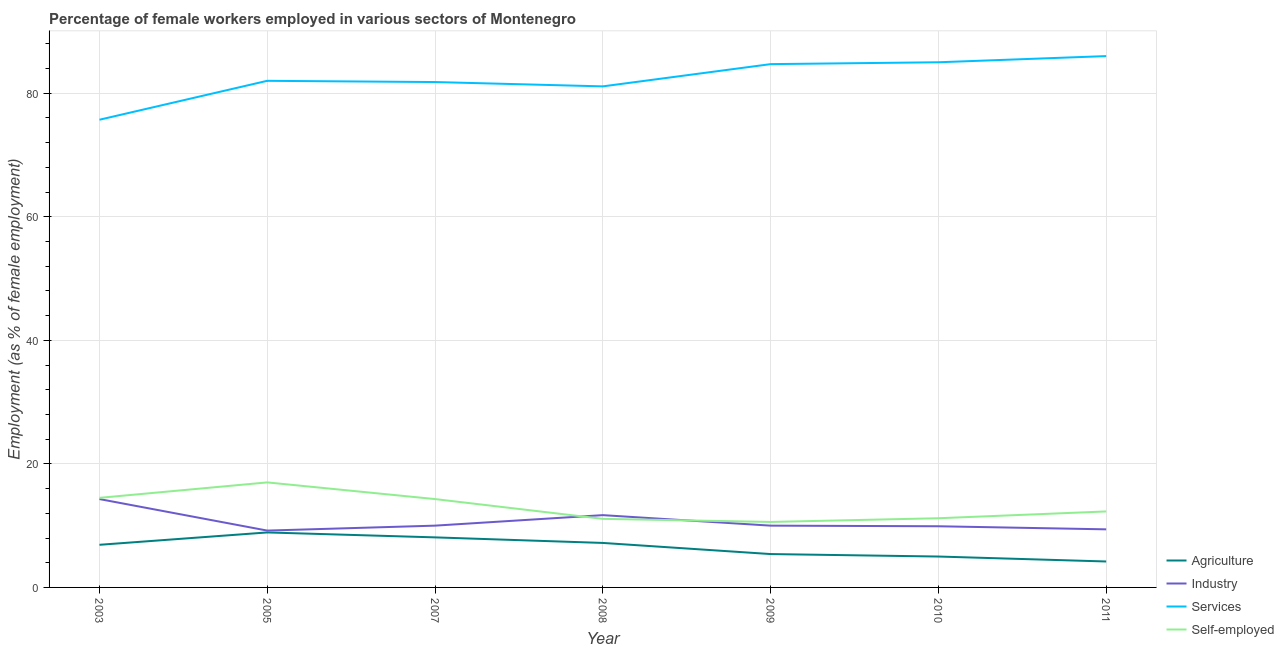Does the line corresponding to percentage of female workers in services intersect with the line corresponding to percentage of female workers in agriculture?
Your answer should be very brief. No. Across all years, what is the minimum percentage of self employed female workers?
Provide a short and direct response. 10.6. In which year was the percentage of self employed female workers maximum?
Make the answer very short. 2005. In which year was the percentage of female workers in industry minimum?
Ensure brevity in your answer.  2005. What is the total percentage of self employed female workers in the graph?
Keep it short and to the point. 91. What is the difference between the percentage of female workers in services in 2011 and the percentage of self employed female workers in 2009?
Give a very brief answer. 75.4. What is the average percentage of female workers in industry per year?
Ensure brevity in your answer.  10.64. In the year 2008, what is the difference between the percentage of female workers in industry and percentage of female workers in agriculture?
Your answer should be compact. 4.5. What is the ratio of the percentage of female workers in services in 2003 to that in 2008?
Give a very brief answer. 0.93. Is the percentage of self employed female workers in 2003 less than that in 2009?
Provide a short and direct response. No. What is the difference between the highest and the second highest percentage of female workers in services?
Your answer should be compact. 1. What is the difference between the highest and the lowest percentage of female workers in services?
Offer a terse response. 10.3. Is the sum of the percentage of female workers in services in 2007 and 2011 greater than the maximum percentage of female workers in agriculture across all years?
Provide a short and direct response. Yes. Is it the case that in every year, the sum of the percentage of female workers in agriculture and percentage of female workers in services is greater than the sum of percentage of female workers in industry and percentage of self employed female workers?
Keep it short and to the point. No. How many years are there in the graph?
Provide a short and direct response. 7. What is the difference between two consecutive major ticks on the Y-axis?
Give a very brief answer. 20. Does the graph contain grids?
Provide a succinct answer. Yes. How many legend labels are there?
Make the answer very short. 4. How are the legend labels stacked?
Your response must be concise. Vertical. What is the title of the graph?
Offer a very short reply. Percentage of female workers employed in various sectors of Montenegro. What is the label or title of the X-axis?
Offer a very short reply. Year. What is the label or title of the Y-axis?
Give a very brief answer. Employment (as % of female employment). What is the Employment (as % of female employment) in Agriculture in 2003?
Keep it short and to the point. 6.9. What is the Employment (as % of female employment) of Industry in 2003?
Your response must be concise. 14.3. What is the Employment (as % of female employment) of Services in 2003?
Provide a succinct answer. 75.7. What is the Employment (as % of female employment) of Agriculture in 2005?
Offer a very short reply. 8.9. What is the Employment (as % of female employment) of Industry in 2005?
Your response must be concise. 9.2. What is the Employment (as % of female employment) of Agriculture in 2007?
Your answer should be compact. 8.1. What is the Employment (as % of female employment) of Services in 2007?
Your answer should be compact. 81.8. What is the Employment (as % of female employment) in Self-employed in 2007?
Offer a very short reply. 14.3. What is the Employment (as % of female employment) in Agriculture in 2008?
Offer a very short reply. 7.2. What is the Employment (as % of female employment) in Industry in 2008?
Make the answer very short. 11.7. What is the Employment (as % of female employment) of Services in 2008?
Your answer should be very brief. 81.1. What is the Employment (as % of female employment) of Self-employed in 2008?
Keep it short and to the point. 11.1. What is the Employment (as % of female employment) in Agriculture in 2009?
Give a very brief answer. 5.4. What is the Employment (as % of female employment) of Services in 2009?
Give a very brief answer. 84.7. What is the Employment (as % of female employment) of Self-employed in 2009?
Keep it short and to the point. 10.6. What is the Employment (as % of female employment) of Industry in 2010?
Your answer should be compact. 9.9. What is the Employment (as % of female employment) in Self-employed in 2010?
Your answer should be compact. 11.2. What is the Employment (as % of female employment) of Agriculture in 2011?
Give a very brief answer. 4.2. What is the Employment (as % of female employment) of Industry in 2011?
Keep it short and to the point. 9.4. What is the Employment (as % of female employment) of Services in 2011?
Make the answer very short. 86. What is the Employment (as % of female employment) of Self-employed in 2011?
Offer a very short reply. 12.3. Across all years, what is the maximum Employment (as % of female employment) of Agriculture?
Offer a terse response. 8.9. Across all years, what is the maximum Employment (as % of female employment) of Industry?
Provide a succinct answer. 14.3. Across all years, what is the maximum Employment (as % of female employment) of Services?
Provide a succinct answer. 86. Across all years, what is the maximum Employment (as % of female employment) in Self-employed?
Offer a terse response. 17. Across all years, what is the minimum Employment (as % of female employment) of Agriculture?
Keep it short and to the point. 4.2. Across all years, what is the minimum Employment (as % of female employment) in Industry?
Make the answer very short. 9.2. Across all years, what is the minimum Employment (as % of female employment) of Services?
Your answer should be compact. 75.7. Across all years, what is the minimum Employment (as % of female employment) in Self-employed?
Your answer should be compact. 10.6. What is the total Employment (as % of female employment) of Agriculture in the graph?
Your answer should be very brief. 45.7. What is the total Employment (as % of female employment) of Industry in the graph?
Provide a succinct answer. 74.5. What is the total Employment (as % of female employment) of Services in the graph?
Ensure brevity in your answer.  576.3. What is the total Employment (as % of female employment) of Self-employed in the graph?
Make the answer very short. 91. What is the difference between the Employment (as % of female employment) in Industry in 2003 and that in 2005?
Your response must be concise. 5.1. What is the difference between the Employment (as % of female employment) in Services in 2003 and that in 2007?
Offer a very short reply. -6.1. What is the difference between the Employment (as % of female employment) of Self-employed in 2003 and that in 2007?
Your answer should be compact. 0.2. What is the difference between the Employment (as % of female employment) in Industry in 2003 and that in 2008?
Your answer should be very brief. 2.6. What is the difference between the Employment (as % of female employment) of Services in 2003 and that in 2008?
Give a very brief answer. -5.4. What is the difference between the Employment (as % of female employment) in Industry in 2003 and that in 2009?
Keep it short and to the point. 4.3. What is the difference between the Employment (as % of female employment) in Services in 2003 and that in 2009?
Keep it short and to the point. -9. What is the difference between the Employment (as % of female employment) of Self-employed in 2003 and that in 2009?
Keep it short and to the point. 3.9. What is the difference between the Employment (as % of female employment) of Agriculture in 2003 and that in 2010?
Provide a succinct answer. 1.9. What is the difference between the Employment (as % of female employment) of Industry in 2003 and that in 2011?
Ensure brevity in your answer.  4.9. What is the difference between the Employment (as % of female employment) of Services in 2003 and that in 2011?
Provide a succinct answer. -10.3. What is the difference between the Employment (as % of female employment) of Self-employed in 2003 and that in 2011?
Keep it short and to the point. 2.2. What is the difference between the Employment (as % of female employment) of Agriculture in 2005 and that in 2008?
Make the answer very short. 1.7. What is the difference between the Employment (as % of female employment) of Services in 2005 and that in 2008?
Ensure brevity in your answer.  0.9. What is the difference between the Employment (as % of female employment) in Agriculture in 2005 and that in 2009?
Offer a terse response. 3.5. What is the difference between the Employment (as % of female employment) of Industry in 2005 and that in 2009?
Offer a very short reply. -0.8. What is the difference between the Employment (as % of female employment) in Services in 2005 and that in 2009?
Give a very brief answer. -2.7. What is the difference between the Employment (as % of female employment) of Agriculture in 2005 and that in 2010?
Your answer should be very brief. 3.9. What is the difference between the Employment (as % of female employment) of Services in 2005 and that in 2010?
Make the answer very short. -3. What is the difference between the Employment (as % of female employment) in Self-employed in 2005 and that in 2010?
Make the answer very short. 5.8. What is the difference between the Employment (as % of female employment) in Agriculture in 2005 and that in 2011?
Your answer should be compact. 4.7. What is the difference between the Employment (as % of female employment) of Industry in 2005 and that in 2011?
Provide a succinct answer. -0.2. What is the difference between the Employment (as % of female employment) of Services in 2005 and that in 2011?
Give a very brief answer. -4. What is the difference between the Employment (as % of female employment) of Self-employed in 2005 and that in 2011?
Offer a very short reply. 4.7. What is the difference between the Employment (as % of female employment) in Agriculture in 2007 and that in 2008?
Your answer should be compact. 0.9. What is the difference between the Employment (as % of female employment) in Industry in 2007 and that in 2008?
Make the answer very short. -1.7. What is the difference between the Employment (as % of female employment) in Self-employed in 2007 and that in 2010?
Offer a terse response. 3.1. What is the difference between the Employment (as % of female employment) of Agriculture in 2007 and that in 2011?
Keep it short and to the point. 3.9. What is the difference between the Employment (as % of female employment) of Industry in 2007 and that in 2011?
Offer a terse response. 0.6. What is the difference between the Employment (as % of female employment) in Agriculture in 2008 and that in 2009?
Keep it short and to the point. 1.8. What is the difference between the Employment (as % of female employment) in Services in 2008 and that in 2009?
Your answer should be compact. -3.6. What is the difference between the Employment (as % of female employment) of Self-employed in 2008 and that in 2009?
Offer a terse response. 0.5. What is the difference between the Employment (as % of female employment) in Agriculture in 2008 and that in 2010?
Provide a succinct answer. 2.2. What is the difference between the Employment (as % of female employment) in Services in 2008 and that in 2010?
Your answer should be compact. -3.9. What is the difference between the Employment (as % of female employment) of Self-employed in 2008 and that in 2011?
Ensure brevity in your answer.  -1.2. What is the difference between the Employment (as % of female employment) of Services in 2009 and that in 2010?
Give a very brief answer. -0.3. What is the difference between the Employment (as % of female employment) in Self-employed in 2009 and that in 2010?
Your answer should be compact. -0.6. What is the difference between the Employment (as % of female employment) of Agriculture in 2009 and that in 2011?
Ensure brevity in your answer.  1.2. What is the difference between the Employment (as % of female employment) of Self-employed in 2009 and that in 2011?
Make the answer very short. -1.7. What is the difference between the Employment (as % of female employment) of Agriculture in 2010 and that in 2011?
Your answer should be compact. 0.8. What is the difference between the Employment (as % of female employment) in Industry in 2010 and that in 2011?
Provide a succinct answer. 0.5. What is the difference between the Employment (as % of female employment) in Services in 2010 and that in 2011?
Give a very brief answer. -1. What is the difference between the Employment (as % of female employment) of Agriculture in 2003 and the Employment (as % of female employment) of Industry in 2005?
Your answer should be compact. -2.3. What is the difference between the Employment (as % of female employment) of Agriculture in 2003 and the Employment (as % of female employment) of Services in 2005?
Make the answer very short. -75.1. What is the difference between the Employment (as % of female employment) of Agriculture in 2003 and the Employment (as % of female employment) of Self-employed in 2005?
Offer a terse response. -10.1. What is the difference between the Employment (as % of female employment) of Industry in 2003 and the Employment (as % of female employment) of Services in 2005?
Provide a short and direct response. -67.7. What is the difference between the Employment (as % of female employment) in Industry in 2003 and the Employment (as % of female employment) in Self-employed in 2005?
Provide a short and direct response. -2.7. What is the difference between the Employment (as % of female employment) of Services in 2003 and the Employment (as % of female employment) of Self-employed in 2005?
Provide a short and direct response. 58.7. What is the difference between the Employment (as % of female employment) in Agriculture in 2003 and the Employment (as % of female employment) in Industry in 2007?
Offer a terse response. -3.1. What is the difference between the Employment (as % of female employment) of Agriculture in 2003 and the Employment (as % of female employment) of Services in 2007?
Offer a very short reply. -74.9. What is the difference between the Employment (as % of female employment) of Industry in 2003 and the Employment (as % of female employment) of Services in 2007?
Give a very brief answer. -67.5. What is the difference between the Employment (as % of female employment) in Industry in 2003 and the Employment (as % of female employment) in Self-employed in 2007?
Offer a terse response. 0. What is the difference between the Employment (as % of female employment) in Services in 2003 and the Employment (as % of female employment) in Self-employed in 2007?
Provide a succinct answer. 61.4. What is the difference between the Employment (as % of female employment) in Agriculture in 2003 and the Employment (as % of female employment) in Services in 2008?
Your answer should be very brief. -74.2. What is the difference between the Employment (as % of female employment) of Agriculture in 2003 and the Employment (as % of female employment) of Self-employed in 2008?
Provide a short and direct response. -4.2. What is the difference between the Employment (as % of female employment) in Industry in 2003 and the Employment (as % of female employment) in Services in 2008?
Your answer should be compact. -66.8. What is the difference between the Employment (as % of female employment) in Services in 2003 and the Employment (as % of female employment) in Self-employed in 2008?
Provide a short and direct response. 64.6. What is the difference between the Employment (as % of female employment) in Agriculture in 2003 and the Employment (as % of female employment) in Services in 2009?
Provide a succinct answer. -77.8. What is the difference between the Employment (as % of female employment) in Industry in 2003 and the Employment (as % of female employment) in Services in 2009?
Ensure brevity in your answer.  -70.4. What is the difference between the Employment (as % of female employment) of Industry in 2003 and the Employment (as % of female employment) of Self-employed in 2009?
Give a very brief answer. 3.7. What is the difference between the Employment (as % of female employment) of Services in 2003 and the Employment (as % of female employment) of Self-employed in 2009?
Your answer should be compact. 65.1. What is the difference between the Employment (as % of female employment) of Agriculture in 2003 and the Employment (as % of female employment) of Services in 2010?
Ensure brevity in your answer.  -78.1. What is the difference between the Employment (as % of female employment) of Agriculture in 2003 and the Employment (as % of female employment) of Self-employed in 2010?
Give a very brief answer. -4.3. What is the difference between the Employment (as % of female employment) in Industry in 2003 and the Employment (as % of female employment) in Services in 2010?
Your response must be concise. -70.7. What is the difference between the Employment (as % of female employment) in Industry in 2003 and the Employment (as % of female employment) in Self-employed in 2010?
Keep it short and to the point. 3.1. What is the difference between the Employment (as % of female employment) in Services in 2003 and the Employment (as % of female employment) in Self-employed in 2010?
Provide a short and direct response. 64.5. What is the difference between the Employment (as % of female employment) in Agriculture in 2003 and the Employment (as % of female employment) in Services in 2011?
Your answer should be very brief. -79.1. What is the difference between the Employment (as % of female employment) in Agriculture in 2003 and the Employment (as % of female employment) in Self-employed in 2011?
Ensure brevity in your answer.  -5.4. What is the difference between the Employment (as % of female employment) of Industry in 2003 and the Employment (as % of female employment) of Services in 2011?
Ensure brevity in your answer.  -71.7. What is the difference between the Employment (as % of female employment) in Services in 2003 and the Employment (as % of female employment) in Self-employed in 2011?
Give a very brief answer. 63.4. What is the difference between the Employment (as % of female employment) of Agriculture in 2005 and the Employment (as % of female employment) of Industry in 2007?
Make the answer very short. -1.1. What is the difference between the Employment (as % of female employment) in Agriculture in 2005 and the Employment (as % of female employment) in Services in 2007?
Make the answer very short. -72.9. What is the difference between the Employment (as % of female employment) in Industry in 2005 and the Employment (as % of female employment) in Services in 2007?
Give a very brief answer. -72.6. What is the difference between the Employment (as % of female employment) in Industry in 2005 and the Employment (as % of female employment) in Self-employed in 2007?
Provide a short and direct response. -5.1. What is the difference between the Employment (as % of female employment) in Services in 2005 and the Employment (as % of female employment) in Self-employed in 2007?
Provide a succinct answer. 67.7. What is the difference between the Employment (as % of female employment) of Agriculture in 2005 and the Employment (as % of female employment) of Industry in 2008?
Your answer should be compact. -2.8. What is the difference between the Employment (as % of female employment) in Agriculture in 2005 and the Employment (as % of female employment) in Services in 2008?
Your response must be concise. -72.2. What is the difference between the Employment (as % of female employment) of Industry in 2005 and the Employment (as % of female employment) of Services in 2008?
Keep it short and to the point. -71.9. What is the difference between the Employment (as % of female employment) in Industry in 2005 and the Employment (as % of female employment) in Self-employed in 2008?
Ensure brevity in your answer.  -1.9. What is the difference between the Employment (as % of female employment) in Services in 2005 and the Employment (as % of female employment) in Self-employed in 2008?
Offer a terse response. 70.9. What is the difference between the Employment (as % of female employment) of Agriculture in 2005 and the Employment (as % of female employment) of Services in 2009?
Provide a succinct answer. -75.8. What is the difference between the Employment (as % of female employment) in Agriculture in 2005 and the Employment (as % of female employment) in Self-employed in 2009?
Your response must be concise. -1.7. What is the difference between the Employment (as % of female employment) of Industry in 2005 and the Employment (as % of female employment) of Services in 2009?
Offer a terse response. -75.5. What is the difference between the Employment (as % of female employment) in Services in 2005 and the Employment (as % of female employment) in Self-employed in 2009?
Make the answer very short. 71.4. What is the difference between the Employment (as % of female employment) of Agriculture in 2005 and the Employment (as % of female employment) of Industry in 2010?
Your answer should be very brief. -1. What is the difference between the Employment (as % of female employment) in Agriculture in 2005 and the Employment (as % of female employment) in Services in 2010?
Your answer should be compact. -76.1. What is the difference between the Employment (as % of female employment) of Industry in 2005 and the Employment (as % of female employment) of Services in 2010?
Your response must be concise. -75.8. What is the difference between the Employment (as % of female employment) of Services in 2005 and the Employment (as % of female employment) of Self-employed in 2010?
Provide a short and direct response. 70.8. What is the difference between the Employment (as % of female employment) of Agriculture in 2005 and the Employment (as % of female employment) of Industry in 2011?
Offer a very short reply. -0.5. What is the difference between the Employment (as % of female employment) of Agriculture in 2005 and the Employment (as % of female employment) of Services in 2011?
Keep it short and to the point. -77.1. What is the difference between the Employment (as % of female employment) in Industry in 2005 and the Employment (as % of female employment) in Services in 2011?
Make the answer very short. -76.8. What is the difference between the Employment (as % of female employment) of Industry in 2005 and the Employment (as % of female employment) of Self-employed in 2011?
Offer a very short reply. -3.1. What is the difference between the Employment (as % of female employment) of Services in 2005 and the Employment (as % of female employment) of Self-employed in 2011?
Ensure brevity in your answer.  69.7. What is the difference between the Employment (as % of female employment) of Agriculture in 2007 and the Employment (as % of female employment) of Industry in 2008?
Make the answer very short. -3.6. What is the difference between the Employment (as % of female employment) in Agriculture in 2007 and the Employment (as % of female employment) in Services in 2008?
Give a very brief answer. -73. What is the difference between the Employment (as % of female employment) in Industry in 2007 and the Employment (as % of female employment) in Services in 2008?
Your answer should be very brief. -71.1. What is the difference between the Employment (as % of female employment) in Services in 2007 and the Employment (as % of female employment) in Self-employed in 2008?
Give a very brief answer. 70.7. What is the difference between the Employment (as % of female employment) in Agriculture in 2007 and the Employment (as % of female employment) in Services in 2009?
Give a very brief answer. -76.6. What is the difference between the Employment (as % of female employment) in Industry in 2007 and the Employment (as % of female employment) in Services in 2009?
Your answer should be very brief. -74.7. What is the difference between the Employment (as % of female employment) in Services in 2007 and the Employment (as % of female employment) in Self-employed in 2009?
Ensure brevity in your answer.  71.2. What is the difference between the Employment (as % of female employment) in Agriculture in 2007 and the Employment (as % of female employment) in Industry in 2010?
Ensure brevity in your answer.  -1.8. What is the difference between the Employment (as % of female employment) in Agriculture in 2007 and the Employment (as % of female employment) in Services in 2010?
Your answer should be compact. -76.9. What is the difference between the Employment (as % of female employment) in Agriculture in 2007 and the Employment (as % of female employment) in Self-employed in 2010?
Give a very brief answer. -3.1. What is the difference between the Employment (as % of female employment) of Industry in 2007 and the Employment (as % of female employment) of Services in 2010?
Offer a terse response. -75. What is the difference between the Employment (as % of female employment) of Services in 2007 and the Employment (as % of female employment) of Self-employed in 2010?
Keep it short and to the point. 70.6. What is the difference between the Employment (as % of female employment) of Agriculture in 2007 and the Employment (as % of female employment) of Industry in 2011?
Give a very brief answer. -1.3. What is the difference between the Employment (as % of female employment) of Agriculture in 2007 and the Employment (as % of female employment) of Services in 2011?
Ensure brevity in your answer.  -77.9. What is the difference between the Employment (as % of female employment) of Agriculture in 2007 and the Employment (as % of female employment) of Self-employed in 2011?
Offer a terse response. -4.2. What is the difference between the Employment (as % of female employment) in Industry in 2007 and the Employment (as % of female employment) in Services in 2011?
Give a very brief answer. -76. What is the difference between the Employment (as % of female employment) in Industry in 2007 and the Employment (as % of female employment) in Self-employed in 2011?
Ensure brevity in your answer.  -2.3. What is the difference between the Employment (as % of female employment) of Services in 2007 and the Employment (as % of female employment) of Self-employed in 2011?
Your answer should be very brief. 69.5. What is the difference between the Employment (as % of female employment) in Agriculture in 2008 and the Employment (as % of female employment) in Services in 2009?
Provide a short and direct response. -77.5. What is the difference between the Employment (as % of female employment) in Industry in 2008 and the Employment (as % of female employment) in Services in 2009?
Offer a very short reply. -73. What is the difference between the Employment (as % of female employment) of Industry in 2008 and the Employment (as % of female employment) of Self-employed in 2009?
Ensure brevity in your answer.  1.1. What is the difference between the Employment (as % of female employment) in Services in 2008 and the Employment (as % of female employment) in Self-employed in 2009?
Your answer should be very brief. 70.5. What is the difference between the Employment (as % of female employment) of Agriculture in 2008 and the Employment (as % of female employment) of Services in 2010?
Ensure brevity in your answer.  -77.8. What is the difference between the Employment (as % of female employment) in Industry in 2008 and the Employment (as % of female employment) in Services in 2010?
Offer a terse response. -73.3. What is the difference between the Employment (as % of female employment) of Industry in 2008 and the Employment (as % of female employment) of Self-employed in 2010?
Your answer should be very brief. 0.5. What is the difference between the Employment (as % of female employment) in Services in 2008 and the Employment (as % of female employment) in Self-employed in 2010?
Give a very brief answer. 69.9. What is the difference between the Employment (as % of female employment) of Agriculture in 2008 and the Employment (as % of female employment) of Industry in 2011?
Offer a terse response. -2.2. What is the difference between the Employment (as % of female employment) of Agriculture in 2008 and the Employment (as % of female employment) of Services in 2011?
Give a very brief answer. -78.8. What is the difference between the Employment (as % of female employment) of Industry in 2008 and the Employment (as % of female employment) of Services in 2011?
Give a very brief answer. -74.3. What is the difference between the Employment (as % of female employment) of Industry in 2008 and the Employment (as % of female employment) of Self-employed in 2011?
Make the answer very short. -0.6. What is the difference between the Employment (as % of female employment) in Services in 2008 and the Employment (as % of female employment) in Self-employed in 2011?
Provide a succinct answer. 68.8. What is the difference between the Employment (as % of female employment) of Agriculture in 2009 and the Employment (as % of female employment) of Services in 2010?
Provide a succinct answer. -79.6. What is the difference between the Employment (as % of female employment) in Agriculture in 2009 and the Employment (as % of female employment) in Self-employed in 2010?
Offer a very short reply. -5.8. What is the difference between the Employment (as % of female employment) of Industry in 2009 and the Employment (as % of female employment) of Services in 2010?
Offer a terse response. -75. What is the difference between the Employment (as % of female employment) of Industry in 2009 and the Employment (as % of female employment) of Self-employed in 2010?
Ensure brevity in your answer.  -1.2. What is the difference between the Employment (as % of female employment) of Services in 2009 and the Employment (as % of female employment) of Self-employed in 2010?
Ensure brevity in your answer.  73.5. What is the difference between the Employment (as % of female employment) of Agriculture in 2009 and the Employment (as % of female employment) of Services in 2011?
Offer a very short reply. -80.6. What is the difference between the Employment (as % of female employment) of Agriculture in 2009 and the Employment (as % of female employment) of Self-employed in 2011?
Your response must be concise. -6.9. What is the difference between the Employment (as % of female employment) in Industry in 2009 and the Employment (as % of female employment) in Services in 2011?
Your response must be concise. -76. What is the difference between the Employment (as % of female employment) in Industry in 2009 and the Employment (as % of female employment) in Self-employed in 2011?
Make the answer very short. -2.3. What is the difference between the Employment (as % of female employment) in Services in 2009 and the Employment (as % of female employment) in Self-employed in 2011?
Your answer should be compact. 72.4. What is the difference between the Employment (as % of female employment) of Agriculture in 2010 and the Employment (as % of female employment) of Services in 2011?
Your response must be concise. -81. What is the difference between the Employment (as % of female employment) in Agriculture in 2010 and the Employment (as % of female employment) in Self-employed in 2011?
Offer a terse response. -7.3. What is the difference between the Employment (as % of female employment) of Industry in 2010 and the Employment (as % of female employment) of Services in 2011?
Provide a short and direct response. -76.1. What is the difference between the Employment (as % of female employment) of Services in 2010 and the Employment (as % of female employment) of Self-employed in 2011?
Your answer should be compact. 72.7. What is the average Employment (as % of female employment) of Agriculture per year?
Keep it short and to the point. 6.53. What is the average Employment (as % of female employment) in Industry per year?
Make the answer very short. 10.64. What is the average Employment (as % of female employment) of Services per year?
Provide a succinct answer. 82.33. What is the average Employment (as % of female employment) in Self-employed per year?
Provide a succinct answer. 13. In the year 2003, what is the difference between the Employment (as % of female employment) of Agriculture and Employment (as % of female employment) of Industry?
Your answer should be compact. -7.4. In the year 2003, what is the difference between the Employment (as % of female employment) of Agriculture and Employment (as % of female employment) of Services?
Offer a terse response. -68.8. In the year 2003, what is the difference between the Employment (as % of female employment) in Agriculture and Employment (as % of female employment) in Self-employed?
Give a very brief answer. -7.6. In the year 2003, what is the difference between the Employment (as % of female employment) of Industry and Employment (as % of female employment) of Services?
Provide a short and direct response. -61.4. In the year 2003, what is the difference between the Employment (as % of female employment) of Industry and Employment (as % of female employment) of Self-employed?
Give a very brief answer. -0.2. In the year 2003, what is the difference between the Employment (as % of female employment) of Services and Employment (as % of female employment) of Self-employed?
Make the answer very short. 61.2. In the year 2005, what is the difference between the Employment (as % of female employment) in Agriculture and Employment (as % of female employment) in Services?
Offer a very short reply. -73.1. In the year 2005, what is the difference between the Employment (as % of female employment) of Agriculture and Employment (as % of female employment) of Self-employed?
Provide a succinct answer. -8.1. In the year 2005, what is the difference between the Employment (as % of female employment) in Industry and Employment (as % of female employment) in Services?
Your answer should be compact. -72.8. In the year 2005, what is the difference between the Employment (as % of female employment) of Services and Employment (as % of female employment) of Self-employed?
Your answer should be very brief. 65. In the year 2007, what is the difference between the Employment (as % of female employment) of Agriculture and Employment (as % of female employment) of Industry?
Make the answer very short. -1.9. In the year 2007, what is the difference between the Employment (as % of female employment) of Agriculture and Employment (as % of female employment) of Services?
Give a very brief answer. -73.7. In the year 2007, what is the difference between the Employment (as % of female employment) in Agriculture and Employment (as % of female employment) in Self-employed?
Your answer should be very brief. -6.2. In the year 2007, what is the difference between the Employment (as % of female employment) in Industry and Employment (as % of female employment) in Services?
Make the answer very short. -71.8. In the year 2007, what is the difference between the Employment (as % of female employment) of Services and Employment (as % of female employment) of Self-employed?
Your answer should be compact. 67.5. In the year 2008, what is the difference between the Employment (as % of female employment) in Agriculture and Employment (as % of female employment) in Services?
Your answer should be very brief. -73.9. In the year 2008, what is the difference between the Employment (as % of female employment) in Industry and Employment (as % of female employment) in Services?
Keep it short and to the point. -69.4. In the year 2008, what is the difference between the Employment (as % of female employment) of Industry and Employment (as % of female employment) of Self-employed?
Your answer should be compact. 0.6. In the year 2009, what is the difference between the Employment (as % of female employment) of Agriculture and Employment (as % of female employment) of Industry?
Your answer should be compact. -4.6. In the year 2009, what is the difference between the Employment (as % of female employment) of Agriculture and Employment (as % of female employment) of Services?
Make the answer very short. -79.3. In the year 2009, what is the difference between the Employment (as % of female employment) of Industry and Employment (as % of female employment) of Services?
Your answer should be very brief. -74.7. In the year 2009, what is the difference between the Employment (as % of female employment) of Services and Employment (as % of female employment) of Self-employed?
Your response must be concise. 74.1. In the year 2010, what is the difference between the Employment (as % of female employment) in Agriculture and Employment (as % of female employment) in Industry?
Ensure brevity in your answer.  -4.9. In the year 2010, what is the difference between the Employment (as % of female employment) of Agriculture and Employment (as % of female employment) of Services?
Provide a succinct answer. -80. In the year 2010, what is the difference between the Employment (as % of female employment) in Agriculture and Employment (as % of female employment) in Self-employed?
Provide a succinct answer. -6.2. In the year 2010, what is the difference between the Employment (as % of female employment) of Industry and Employment (as % of female employment) of Services?
Keep it short and to the point. -75.1. In the year 2010, what is the difference between the Employment (as % of female employment) of Industry and Employment (as % of female employment) of Self-employed?
Ensure brevity in your answer.  -1.3. In the year 2010, what is the difference between the Employment (as % of female employment) of Services and Employment (as % of female employment) of Self-employed?
Your response must be concise. 73.8. In the year 2011, what is the difference between the Employment (as % of female employment) of Agriculture and Employment (as % of female employment) of Industry?
Make the answer very short. -5.2. In the year 2011, what is the difference between the Employment (as % of female employment) in Agriculture and Employment (as % of female employment) in Services?
Your answer should be compact. -81.8. In the year 2011, what is the difference between the Employment (as % of female employment) of Agriculture and Employment (as % of female employment) of Self-employed?
Ensure brevity in your answer.  -8.1. In the year 2011, what is the difference between the Employment (as % of female employment) of Industry and Employment (as % of female employment) of Services?
Offer a terse response. -76.6. In the year 2011, what is the difference between the Employment (as % of female employment) of Services and Employment (as % of female employment) of Self-employed?
Provide a short and direct response. 73.7. What is the ratio of the Employment (as % of female employment) in Agriculture in 2003 to that in 2005?
Offer a very short reply. 0.78. What is the ratio of the Employment (as % of female employment) in Industry in 2003 to that in 2005?
Your answer should be very brief. 1.55. What is the ratio of the Employment (as % of female employment) of Services in 2003 to that in 2005?
Your response must be concise. 0.92. What is the ratio of the Employment (as % of female employment) in Self-employed in 2003 to that in 2005?
Offer a very short reply. 0.85. What is the ratio of the Employment (as % of female employment) of Agriculture in 2003 to that in 2007?
Provide a succinct answer. 0.85. What is the ratio of the Employment (as % of female employment) in Industry in 2003 to that in 2007?
Offer a very short reply. 1.43. What is the ratio of the Employment (as % of female employment) in Services in 2003 to that in 2007?
Provide a succinct answer. 0.93. What is the ratio of the Employment (as % of female employment) of Agriculture in 2003 to that in 2008?
Make the answer very short. 0.96. What is the ratio of the Employment (as % of female employment) of Industry in 2003 to that in 2008?
Your response must be concise. 1.22. What is the ratio of the Employment (as % of female employment) of Services in 2003 to that in 2008?
Your answer should be very brief. 0.93. What is the ratio of the Employment (as % of female employment) of Self-employed in 2003 to that in 2008?
Your response must be concise. 1.31. What is the ratio of the Employment (as % of female employment) in Agriculture in 2003 to that in 2009?
Provide a succinct answer. 1.28. What is the ratio of the Employment (as % of female employment) in Industry in 2003 to that in 2009?
Ensure brevity in your answer.  1.43. What is the ratio of the Employment (as % of female employment) in Services in 2003 to that in 2009?
Make the answer very short. 0.89. What is the ratio of the Employment (as % of female employment) in Self-employed in 2003 to that in 2009?
Give a very brief answer. 1.37. What is the ratio of the Employment (as % of female employment) in Agriculture in 2003 to that in 2010?
Your answer should be compact. 1.38. What is the ratio of the Employment (as % of female employment) in Industry in 2003 to that in 2010?
Your answer should be compact. 1.44. What is the ratio of the Employment (as % of female employment) in Services in 2003 to that in 2010?
Your response must be concise. 0.89. What is the ratio of the Employment (as % of female employment) of Self-employed in 2003 to that in 2010?
Ensure brevity in your answer.  1.29. What is the ratio of the Employment (as % of female employment) in Agriculture in 2003 to that in 2011?
Provide a succinct answer. 1.64. What is the ratio of the Employment (as % of female employment) of Industry in 2003 to that in 2011?
Offer a very short reply. 1.52. What is the ratio of the Employment (as % of female employment) in Services in 2003 to that in 2011?
Your answer should be very brief. 0.88. What is the ratio of the Employment (as % of female employment) in Self-employed in 2003 to that in 2011?
Provide a short and direct response. 1.18. What is the ratio of the Employment (as % of female employment) in Agriculture in 2005 to that in 2007?
Your response must be concise. 1.1. What is the ratio of the Employment (as % of female employment) in Industry in 2005 to that in 2007?
Your response must be concise. 0.92. What is the ratio of the Employment (as % of female employment) of Self-employed in 2005 to that in 2007?
Offer a terse response. 1.19. What is the ratio of the Employment (as % of female employment) in Agriculture in 2005 to that in 2008?
Your answer should be very brief. 1.24. What is the ratio of the Employment (as % of female employment) of Industry in 2005 to that in 2008?
Offer a very short reply. 0.79. What is the ratio of the Employment (as % of female employment) in Services in 2005 to that in 2008?
Your answer should be compact. 1.01. What is the ratio of the Employment (as % of female employment) of Self-employed in 2005 to that in 2008?
Make the answer very short. 1.53. What is the ratio of the Employment (as % of female employment) in Agriculture in 2005 to that in 2009?
Keep it short and to the point. 1.65. What is the ratio of the Employment (as % of female employment) in Services in 2005 to that in 2009?
Make the answer very short. 0.97. What is the ratio of the Employment (as % of female employment) in Self-employed in 2005 to that in 2009?
Your answer should be very brief. 1.6. What is the ratio of the Employment (as % of female employment) in Agriculture in 2005 to that in 2010?
Your answer should be compact. 1.78. What is the ratio of the Employment (as % of female employment) in Industry in 2005 to that in 2010?
Ensure brevity in your answer.  0.93. What is the ratio of the Employment (as % of female employment) of Services in 2005 to that in 2010?
Ensure brevity in your answer.  0.96. What is the ratio of the Employment (as % of female employment) in Self-employed in 2005 to that in 2010?
Offer a very short reply. 1.52. What is the ratio of the Employment (as % of female employment) of Agriculture in 2005 to that in 2011?
Ensure brevity in your answer.  2.12. What is the ratio of the Employment (as % of female employment) in Industry in 2005 to that in 2011?
Your response must be concise. 0.98. What is the ratio of the Employment (as % of female employment) of Services in 2005 to that in 2011?
Your answer should be compact. 0.95. What is the ratio of the Employment (as % of female employment) in Self-employed in 2005 to that in 2011?
Provide a short and direct response. 1.38. What is the ratio of the Employment (as % of female employment) in Agriculture in 2007 to that in 2008?
Offer a very short reply. 1.12. What is the ratio of the Employment (as % of female employment) in Industry in 2007 to that in 2008?
Ensure brevity in your answer.  0.85. What is the ratio of the Employment (as % of female employment) in Services in 2007 to that in 2008?
Ensure brevity in your answer.  1.01. What is the ratio of the Employment (as % of female employment) in Self-employed in 2007 to that in 2008?
Your answer should be compact. 1.29. What is the ratio of the Employment (as % of female employment) of Agriculture in 2007 to that in 2009?
Make the answer very short. 1.5. What is the ratio of the Employment (as % of female employment) of Services in 2007 to that in 2009?
Ensure brevity in your answer.  0.97. What is the ratio of the Employment (as % of female employment) in Self-employed in 2007 to that in 2009?
Your answer should be compact. 1.35. What is the ratio of the Employment (as % of female employment) of Agriculture in 2007 to that in 2010?
Make the answer very short. 1.62. What is the ratio of the Employment (as % of female employment) of Industry in 2007 to that in 2010?
Provide a succinct answer. 1.01. What is the ratio of the Employment (as % of female employment) of Services in 2007 to that in 2010?
Your answer should be very brief. 0.96. What is the ratio of the Employment (as % of female employment) in Self-employed in 2007 to that in 2010?
Offer a very short reply. 1.28. What is the ratio of the Employment (as % of female employment) in Agriculture in 2007 to that in 2011?
Keep it short and to the point. 1.93. What is the ratio of the Employment (as % of female employment) in Industry in 2007 to that in 2011?
Offer a very short reply. 1.06. What is the ratio of the Employment (as % of female employment) in Services in 2007 to that in 2011?
Make the answer very short. 0.95. What is the ratio of the Employment (as % of female employment) in Self-employed in 2007 to that in 2011?
Your answer should be compact. 1.16. What is the ratio of the Employment (as % of female employment) in Industry in 2008 to that in 2009?
Provide a short and direct response. 1.17. What is the ratio of the Employment (as % of female employment) of Services in 2008 to that in 2009?
Your answer should be very brief. 0.96. What is the ratio of the Employment (as % of female employment) in Self-employed in 2008 to that in 2009?
Provide a short and direct response. 1.05. What is the ratio of the Employment (as % of female employment) in Agriculture in 2008 to that in 2010?
Provide a short and direct response. 1.44. What is the ratio of the Employment (as % of female employment) of Industry in 2008 to that in 2010?
Provide a short and direct response. 1.18. What is the ratio of the Employment (as % of female employment) in Services in 2008 to that in 2010?
Offer a very short reply. 0.95. What is the ratio of the Employment (as % of female employment) of Agriculture in 2008 to that in 2011?
Offer a very short reply. 1.71. What is the ratio of the Employment (as % of female employment) of Industry in 2008 to that in 2011?
Ensure brevity in your answer.  1.24. What is the ratio of the Employment (as % of female employment) in Services in 2008 to that in 2011?
Give a very brief answer. 0.94. What is the ratio of the Employment (as % of female employment) in Self-employed in 2008 to that in 2011?
Ensure brevity in your answer.  0.9. What is the ratio of the Employment (as % of female employment) of Agriculture in 2009 to that in 2010?
Provide a short and direct response. 1.08. What is the ratio of the Employment (as % of female employment) in Self-employed in 2009 to that in 2010?
Provide a succinct answer. 0.95. What is the ratio of the Employment (as % of female employment) of Agriculture in 2009 to that in 2011?
Provide a succinct answer. 1.29. What is the ratio of the Employment (as % of female employment) of Industry in 2009 to that in 2011?
Your answer should be compact. 1.06. What is the ratio of the Employment (as % of female employment) in Services in 2009 to that in 2011?
Offer a very short reply. 0.98. What is the ratio of the Employment (as % of female employment) in Self-employed in 2009 to that in 2011?
Offer a terse response. 0.86. What is the ratio of the Employment (as % of female employment) of Agriculture in 2010 to that in 2011?
Provide a succinct answer. 1.19. What is the ratio of the Employment (as % of female employment) of Industry in 2010 to that in 2011?
Give a very brief answer. 1.05. What is the ratio of the Employment (as % of female employment) of Services in 2010 to that in 2011?
Ensure brevity in your answer.  0.99. What is the ratio of the Employment (as % of female employment) in Self-employed in 2010 to that in 2011?
Ensure brevity in your answer.  0.91. What is the difference between the highest and the second highest Employment (as % of female employment) of Agriculture?
Offer a very short reply. 0.8. What is the difference between the highest and the second highest Employment (as % of female employment) in Self-employed?
Provide a short and direct response. 2.5. What is the difference between the highest and the lowest Employment (as % of female employment) in Services?
Keep it short and to the point. 10.3. 